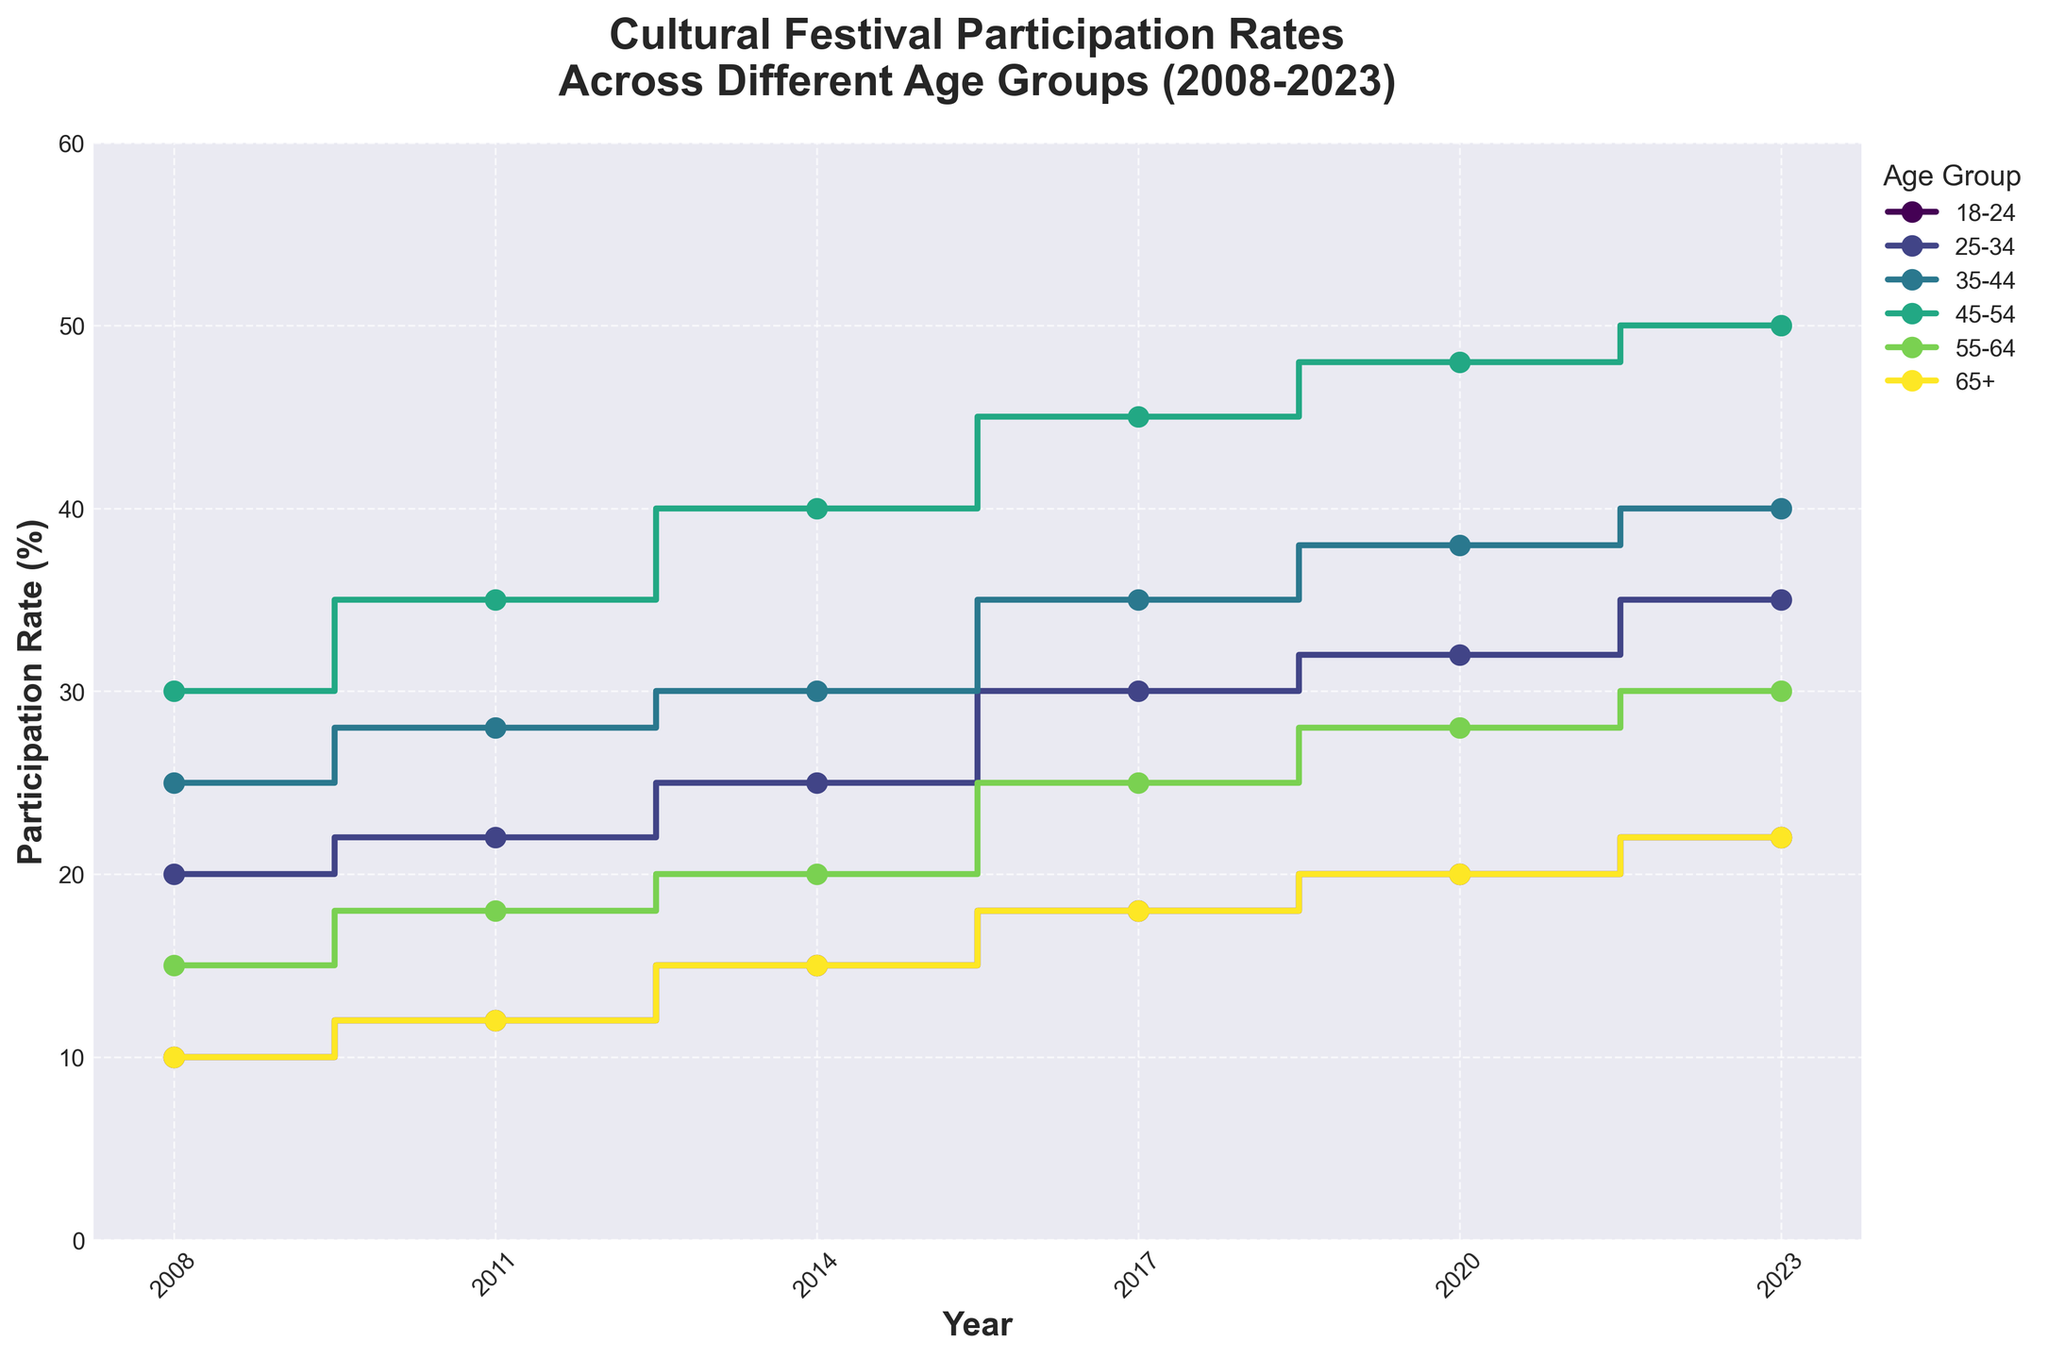What is the title of the plot? The title is usually found at the top or near the top of the plot. It provides a brief description of what the plot depicts. In this case, it reads 'Cultural Festival Participation Rates Across Different Age Groups (2008-2023).'
Answer: Cultural Festival Participation Rates Across Different Age Groups (2008-2023) How many different age groups are there in the plot? By examining the legend, which lists the age groups, we can count the number of unique age groups visualized. In this case, there are six different age groups.
Answer: 6 Which age group had the highest participation rate in 2023? To find this, locate the year 2023 on the x-axis and then check the respective lines for each age group. The highest point for 2023 is the age group 45-54 with a participation rate of 50%.
Answer: 45-54 What is the participation rate for the 25-34 age group in 2014? Locate the year 2014 along the x-axis and follow vertically to the line for the age group 25-34. The participation rate here is 25%.
Answer: 25% Which age group showed the most significant increase in participation rate between 2008 and 2023? To determine this, find the difference between the 2023 and 2008 participation rates for all age groups and identify the maximum difference. The age group 45-54 went from 30% in 2008 to 50% in 2023, an increase of 20 percentage points.
Answer: 45-54 What's the average participation rate of the 35-44 age group over the years provided? Calculate the average by summing participation rates for 2008, 2011, 2014, 2017, 2020, and 2023 (25 + 28 + 30 + 35 + 38 + 40 = 196) and then divide by the number of years (6). The average participation rate is 196/6 = 32.67%.
Answer: 32.67% Which years show a participation rate increase in the 18-24 age group compared to the previous data points? Compare the participation rates for the 18-24 age group for consecutive years. Increases occurred from 2008 (10%) to 2011 (12%), from 2011 (12%) to 2014 (15%), from 2014 (15%) to 2017 (18%), from 2017 (18%) to 2020 (20%), and from 2020 (20%) to 2023 (22%).
Answer: 2011, 2014, 2017, 2020, 2023 Between which consecutive years did the 55-64 age group see the smallest increase in participation rates? To find the smallest increase, examine the difference between each pair of consecutive years for the 55-64 age group. The smallest increase is between 2014 (20%) and 2017 (25%), which is a 5 percentage point increase.
Answer: 2014-2017 What is the overall trend observed in the participation rates of the 65+ age group? Track the 65+ group's participation rates across all years. Starting from 2008 (10%), it consistently increases through 2023 (22%). The trend is a gradual increase over the years.
Answer: Increasing 